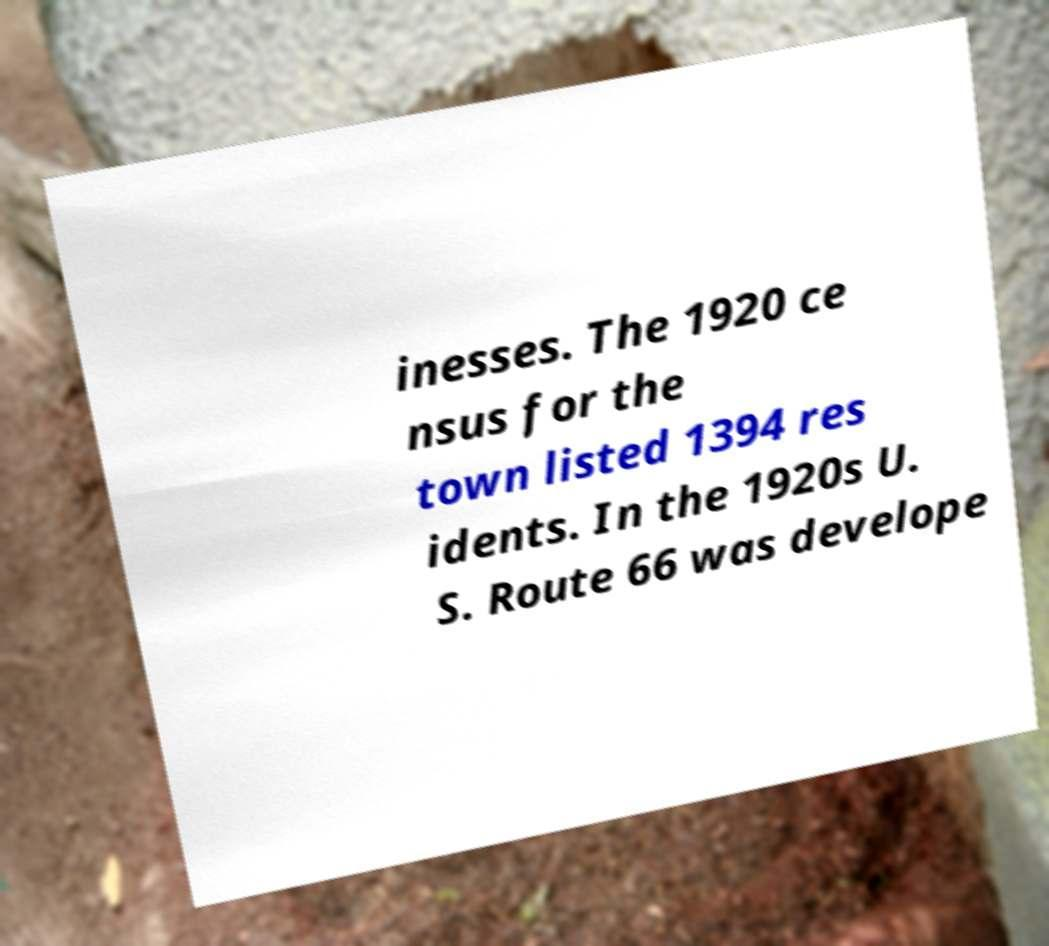For documentation purposes, I need the text within this image transcribed. Could you provide that? inesses. The 1920 ce nsus for the town listed 1394 res idents. In the 1920s U. S. Route 66 was develope 